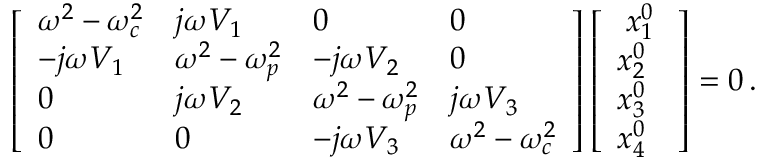Convert formula to latex. <formula><loc_0><loc_0><loc_500><loc_500>\left [ \begin{array} { l l l l } { { \omega } ^ { 2 } - { \omega } _ { c } ^ { 2 } } & { j { \omega } V _ { 1 } } & { 0 } & { 0 } \\ { - j { \omega } V _ { 1 } } & { { \omega } ^ { 2 } - { \omega } _ { p } ^ { 2 } } & { - j { \omega } V _ { 2 } } & { 0 } \\ { 0 } & { j { \omega } V _ { 2 } } & { { \omega } ^ { 2 } - { \omega } _ { p } ^ { 2 } } & { j { \omega } V _ { 3 } } \\ { 0 } & { 0 } & { - j { \omega } V _ { 3 } } & { { \omega } ^ { 2 } - { \omega } _ { c } ^ { 2 } } \end{array} \right ] \left [ \begin{array} { l } { \, x _ { 1 } ^ { 0 } \, } \\ { x _ { 2 } ^ { 0 } } \\ { x _ { 3 } ^ { 0 } } \\ { x _ { 4 } ^ { 0 } } \end{array} \right ] = 0 \, .</formula> 